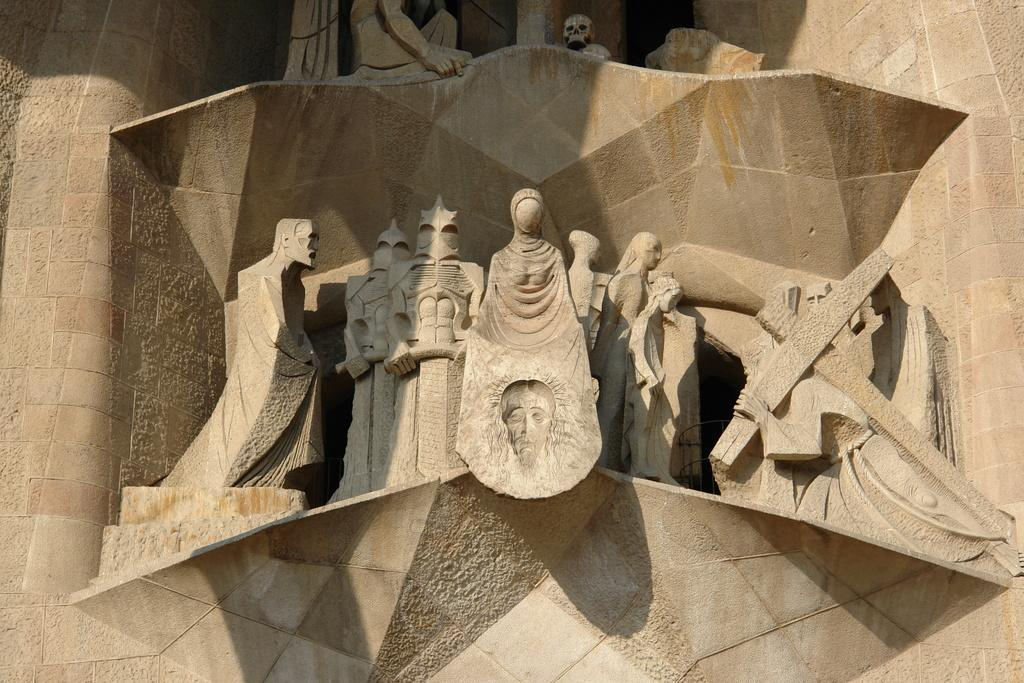What is depicted on the stone in the image? There are carvings of people on a stone in the image. Can you describe the carvings in more detail? The carvings are of people, but the specific details of their appearance or actions cannot be determined from the provided facts. What material is the stone made of? The material of the stone is not specified in the provided facts. How many horses are present in the image? There are no horses present in the image; it features carvings of people on a stone. 